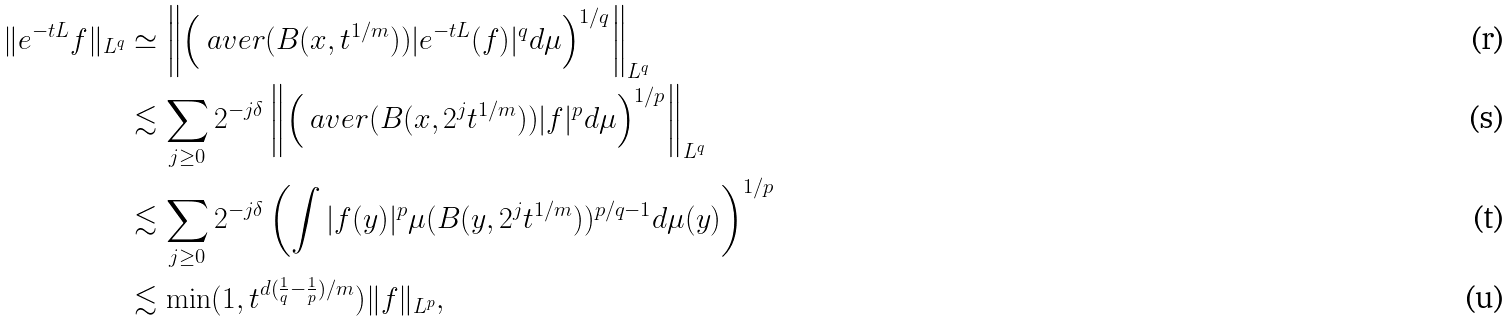Convert formula to latex. <formula><loc_0><loc_0><loc_500><loc_500>\| e ^ { - t L } f \| _ { L ^ { q } } & \simeq \left \| \left ( \ a v e r { ( B ( x , t ^ { 1 / m } ) ) } | e ^ { - t L } ( f ) | ^ { q } d \mu \right ) ^ { 1 / q } \right \| _ { L ^ { q } } \\ & \lesssim \sum _ { j \geq 0 } 2 ^ { - j \delta } \left \| \left ( \ a v e r { ( B ( x , 2 ^ { j } t ^ { 1 / m } ) ) } | f | ^ { p } d \mu \right ) ^ { 1 / p } \right \| _ { L ^ { q } } \\ & \lesssim \sum _ { j \geq 0 } 2 ^ { - j \delta } \left ( \int | f ( y ) | ^ { p } \mu ( B ( y , 2 ^ { j } t ^ { 1 / m } ) ) ^ { p / q - 1 } d \mu ( y ) \right ) ^ { 1 / p } \\ & \lesssim \min ( 1 , t ^ { d ( \frac { 1 } { q } - \frac { 1 } { p } ) / m } ) \| f \| _ { L ^ { p } } ,</formula> 